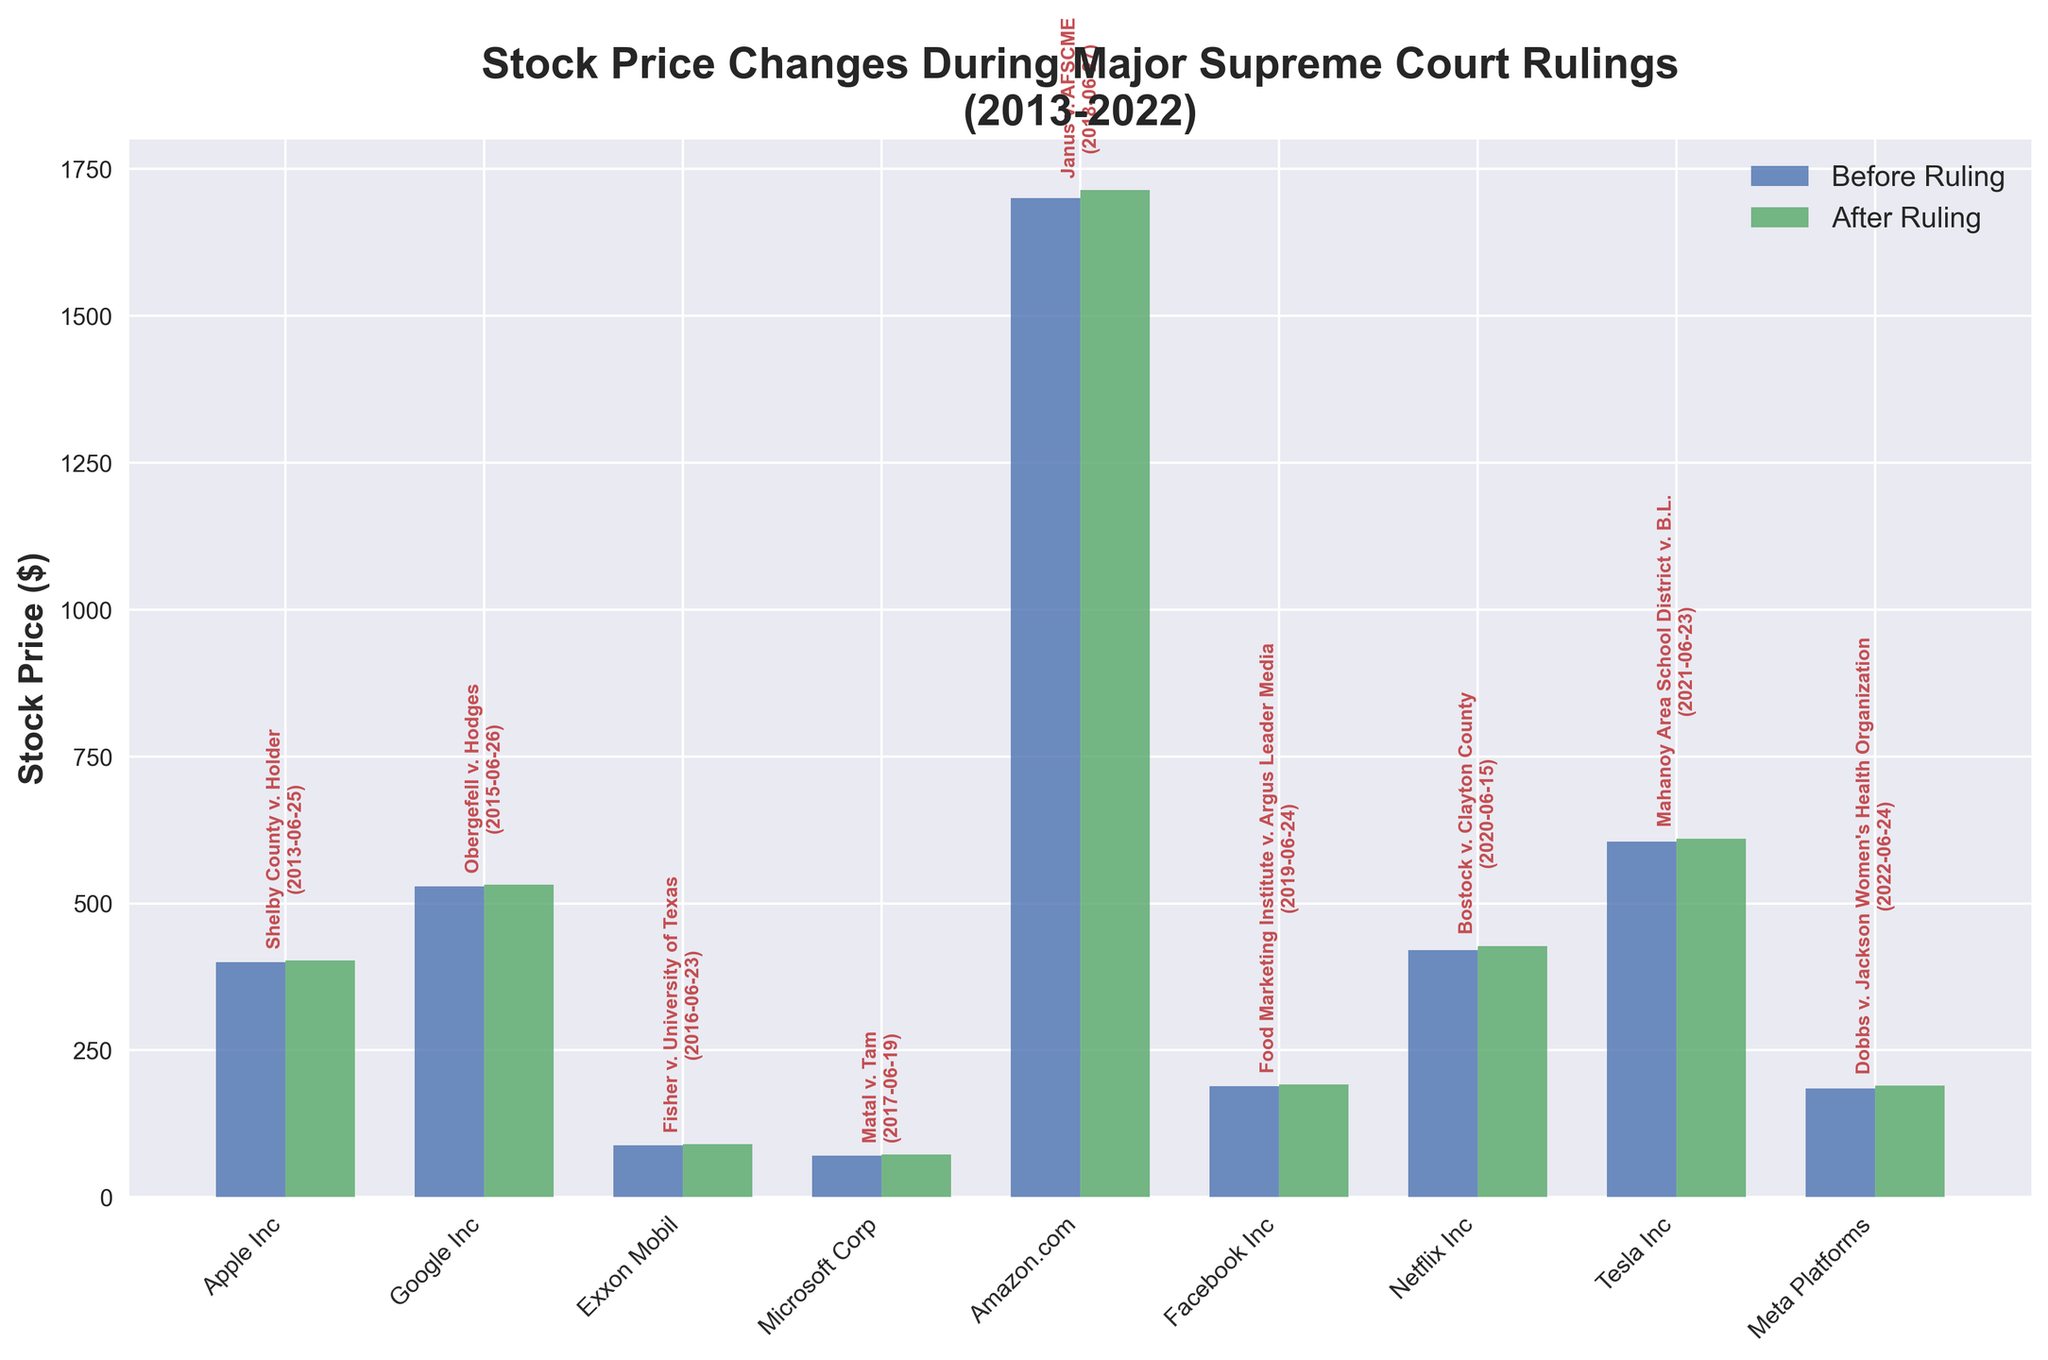What is the title of the figure? The title is usually at the top of the figure and describes its subject. In this case, the title is "Stock Price Changes During Major Supreme Court Rulings (2013-2022)."
Answer: Stock Price Changes During Major Supreme Court Rulings (2013-2022) Which company had the highest stock price after a Supreme Court ruling? By examining the heights of the green bars representing the stock prices after the rulings, the company with the highest stock price is Amazon.com.
Answer: Amazon.com How did Apple's stock price change after the Shelby County v. Holder ruling? To find this, observe the two bars corresponding to Apple Inc. The blue bar shows the price before the ruling, and the green bar shows the price after. The before price is $399.50, and the after price is $402.63. The change is $402.63 - $399.50.
Answer: Increased by $3.13 Which company experienced the smallest percentage increase in stock price after the ruling? First, you need to calculate the percentage increase for each company using the formula: [(StockPriceAfter - StockPriceBefore) / StockPriceBefore] * 100. The lowest percentage increase is for Meta Platforms.
Answer: Meta Platforms What was the stock price of Facebook Inc. before and after the Food Marketing Institute v. Argus Leader Media ruling? The figure indicates two bars for Facebook Inc., representing stock prices before and after the ruling. The blue bar shows the price before, and the green bar shows the price after.
Answer: Before: $189.00, After: $191.62 Which year's Supreme Court ruling had the most significant positive impact on the stock price of the corresponding company? By comparing the difference in the heights of the bars for each year, the most significant positive impact appears to be for Netflix Inc. in 2020.
Answer: 2020 (Bostock v. Clayton County) Did Tesla Inc. experience a stock price increase or decrease after the Mahanoy Area School District v. B.L. ruling? Check the bars for Tesla Inc. The green bar representing the stock price after the ruling is higher than the blue bar representing the stock price before the ruling, indicating an increase.
Answer: Increase Which company had the closest stock prices before and after a ruling? Closest means the smallest difference in bar heights. The smallest difference is observed for Exxon Mobil.
Answer: Exxon Mobil List the companies that had more than a $10 increase in stock price after a ruling. By comparing the bar heights, the companies are Amazon.com and Netflix Inc.
Answer: Amazon.com, Netflix Inc 